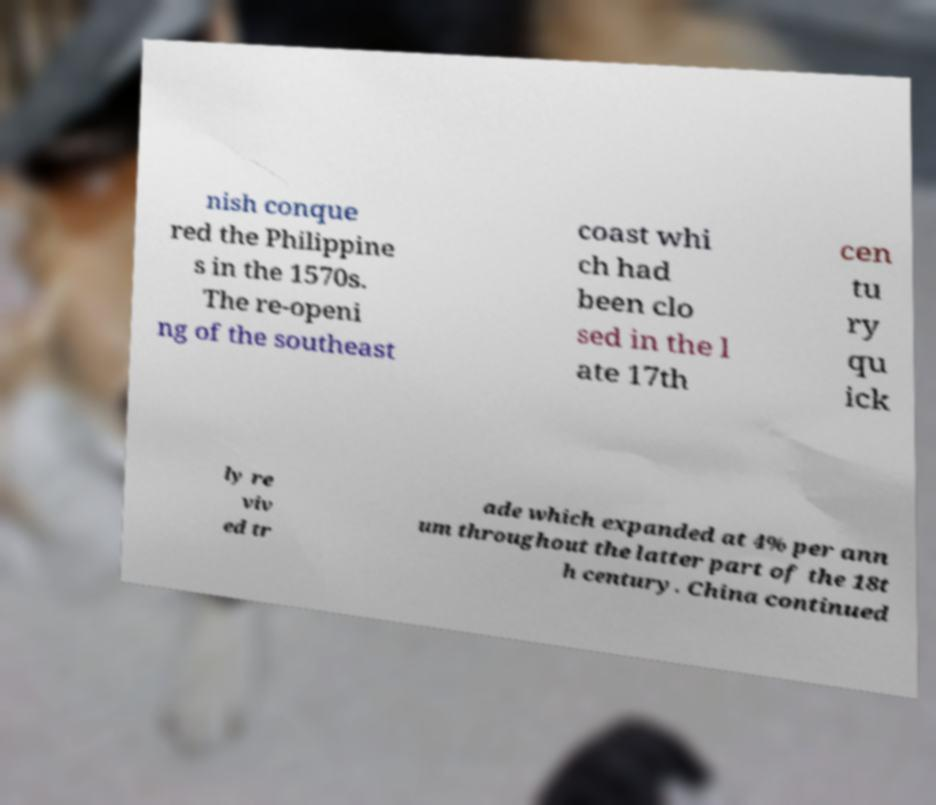Please identify and transcribe the text found in this image. nish conque red the Philippine s in the 1570s. The re-openi ng of the southeast coast whi ch had been clo sed in the l ate 17th cen tu ry qu ick ly re viv ed tr ade which expanded at 4% per ann um throughout the latter part of the 18t h century. China continued 